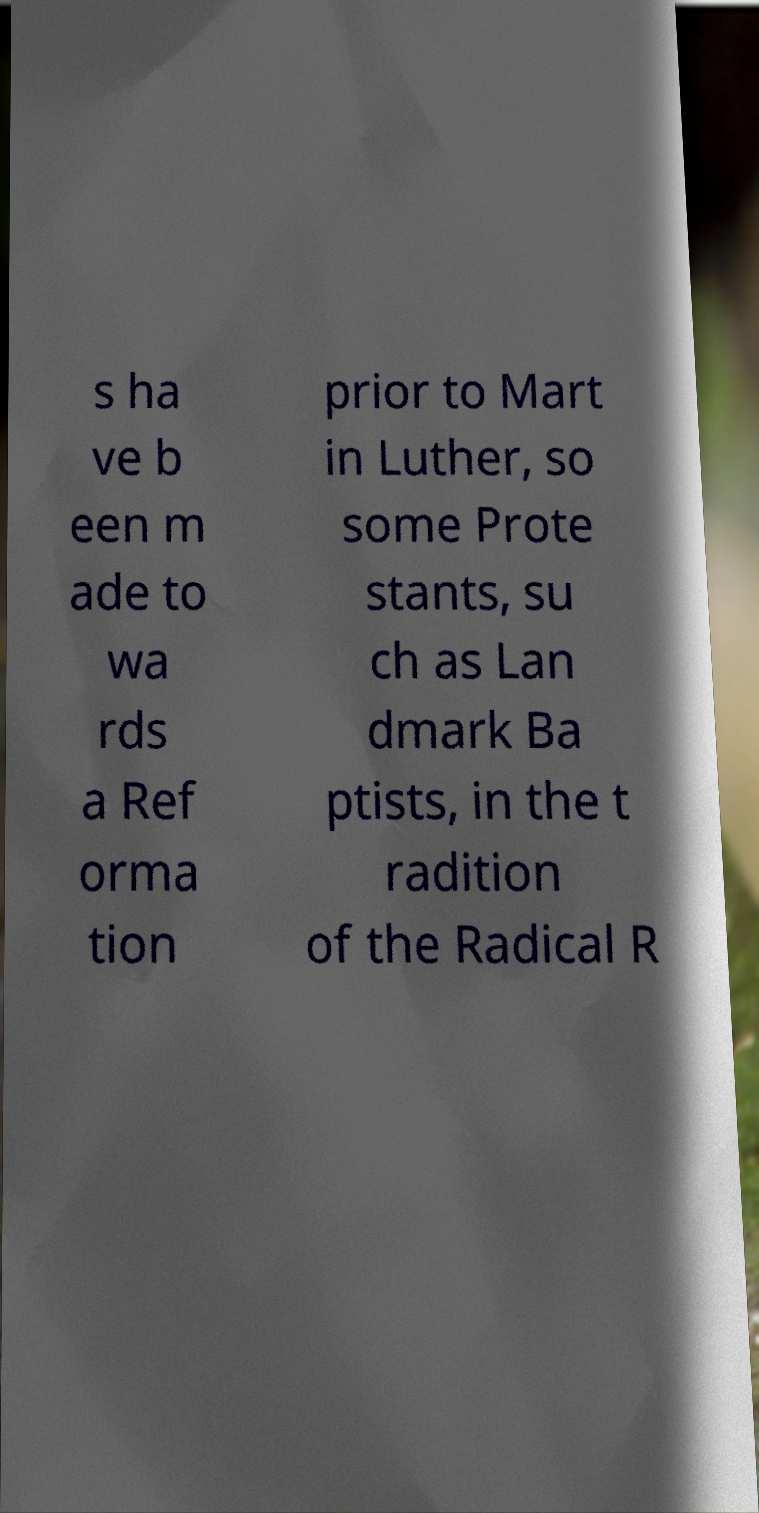Please read and relay the text visible in this image. What does it say? s ha ve b een m ade to wa rds a Ref orma tion prior to Mart in Luther, so some Prote stants, su ch as Lan dmark Ba ptists, in the t radition of the Radical R 